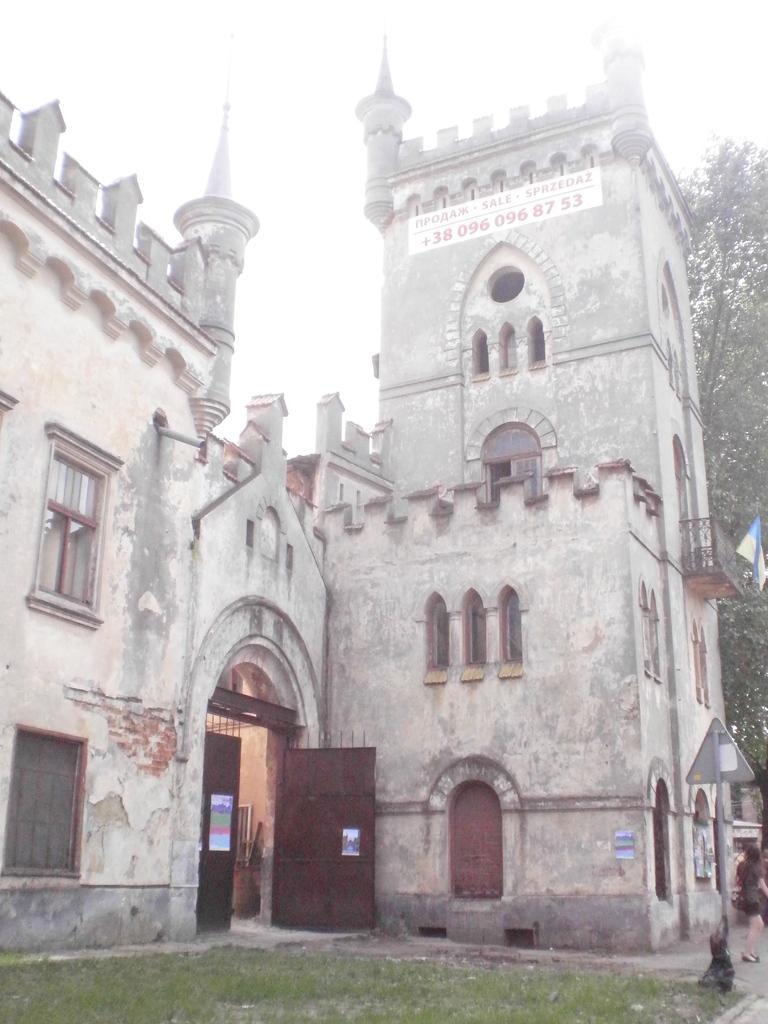What type of structure is present in the picture? There is a building in the picture. What is the purpose of the gates in the picture? The gates are likely used for access control or to define the boundaries of the property. What type of vegetation can be seen in the picture? There is grass visible in the picture. What can be seen in the background of the picture? There are trees and the sky visible in the background of the picture. Where are the tomatoes growing in the picture? There are no tomatoes present in the image. What type of magic is being performed in the picture? There is no magic or any indication of magical activity in the image. 